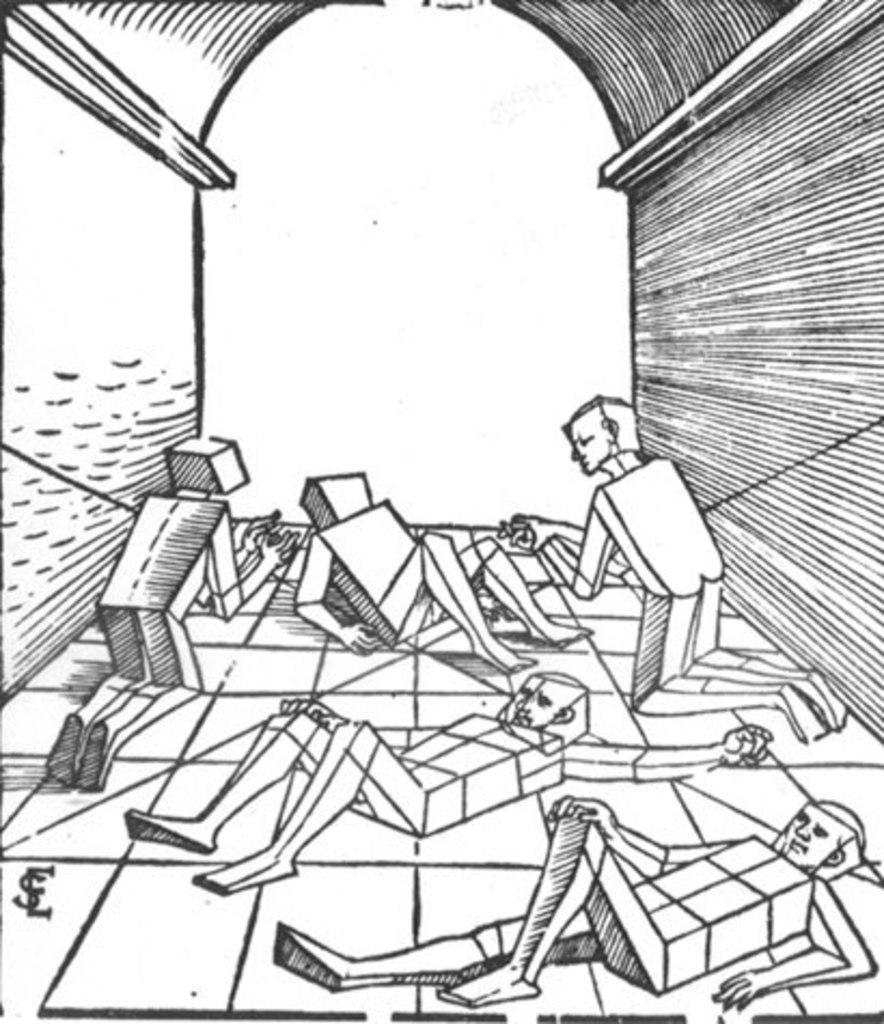What type of drawing is present in the image? The image contains a sketch. What is depicted in the sketch? There are people and a wall in the sketch. What are some of the people in the sketch doing? Some people are lying on the floor in the sketch. What is the weight of the people in the sketch? The weight of the people in the sketch cannot be determined from the image. 